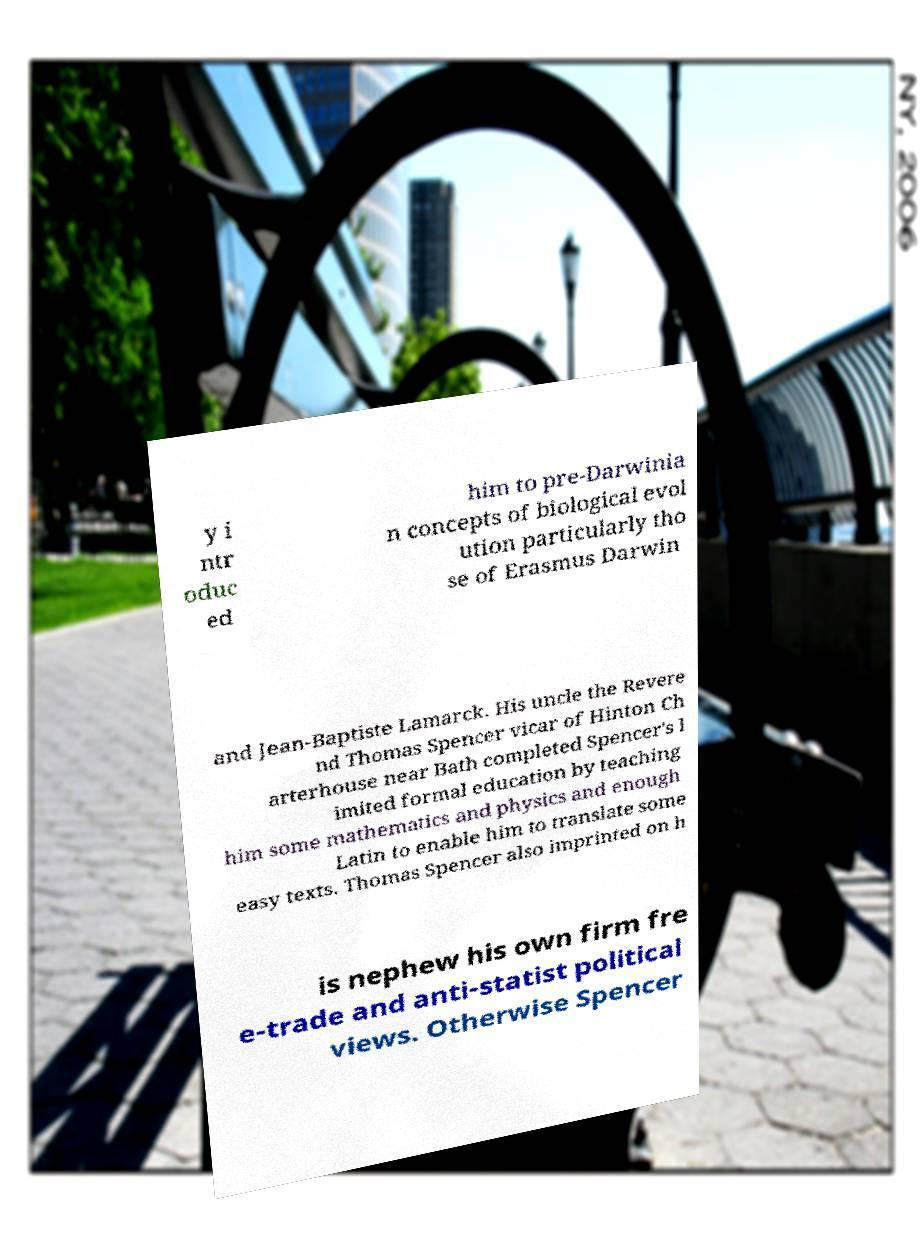There's text embedded in this image that I need extracted. Can you transcribe it verbatim? y i ntr oduc ed him to pre-Darwinia n concepts of biological evol ution particularly tho se of Erasmus Darwin and Jean-Baptiste Lamarck. His uncle the Revere nd Thomas Spencer vicar of Hinton Ch arterhouse near Bath completed Spencer's l imited formal education by teaching him some mathematics and physics and enough Latin to enable him to translate some easy texts. Thomas Spencer also imprinted on h is nephew his own firm fre e-trade and anti-statist political views. Otherwise Spencer 